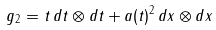Convert formula to latex. <formula><loc_0><loc_0><loc_500><loc_500>g _ { 2 } = t \, d t \otimes d t + a ( t ) ^ { 2 } \, d x \otimes d x</formula> 